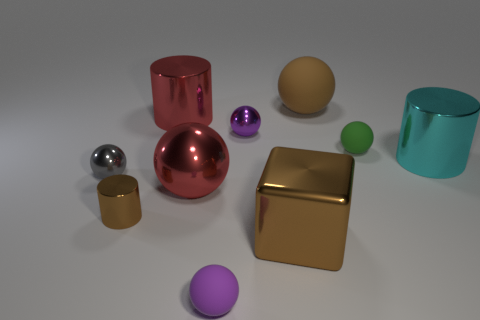What number of other things are there of the same shape as the cyan object?
Provide a succinct answer. 2. There is a large red metallic object in front of the gray shiny sphere; what is its shape?
Make the answer very short. Sphere. There is a brown thing that is behind the gray metallic object; does it have the same shape as the large red object on the right side of the red shiny cylinder?
Offer a terse response. Yes. Are there the same number of small green rubber things that are right of the green sphere and small gray matte cylinders?
Keep it short and to the point. Yes. There is a red object that is the same shape as the small brown shiny thing; what is it made of?
Ensure brevity in your answer.  Metal. What shape is the large brown thing that is in front of the metal object that is right of the small green rubber object?
Your response must be concise. Cube. Does the big object that is behind the large red metallic cylinder have the same material as the green sphere?
Keep it short and to the point. Yes. Are there the same number of big cylinders behind the tiny purple metal object and red objects that are left of the red ball?
Give a very brief answer. Yes. What is the material of the small cylinder that is the same color as the block?
Keep it short and to the point. Metal. How many big brown shiny cubes are to the right of the tiny thing that is right of the big brown matte object?
Offer a very short reply. 0. 